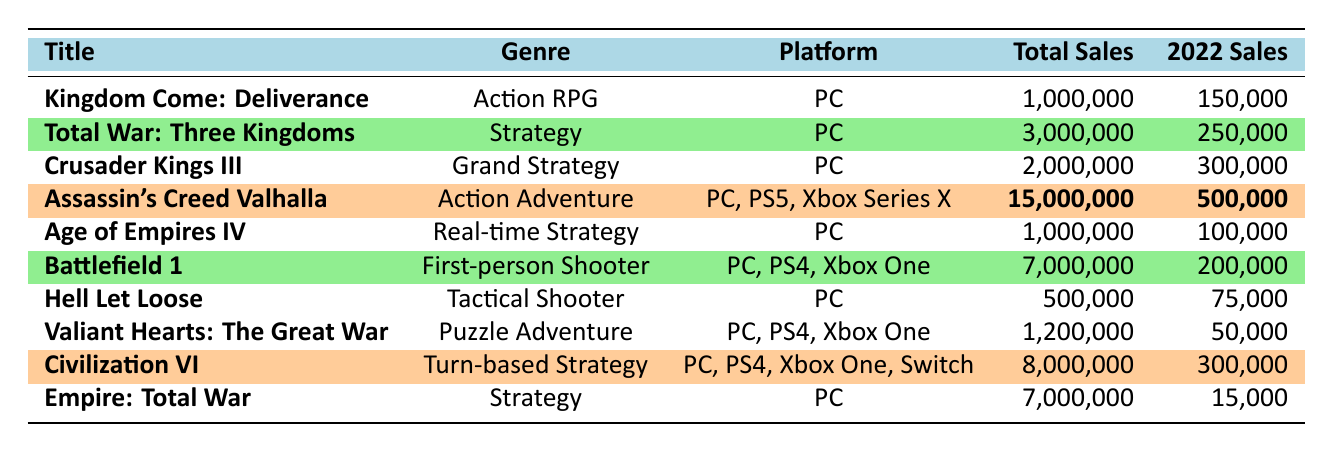What is the genre of "Total War: Three Kingdoms"? The table shows the title "Total War: Three Kingdoms" in the first column and the genre listed next to it in the second column. The genre is "Strategy."
Answer: Strategy How many copies of "Assassin's Creed Valhalla" sold in 2022? The row for "Assassin's Creed Valhalla" states that its sales in 2022 were 500,000 copies.
Answer: 500,000 Which game had the highest total sales? Looking at the total sales column, "Assassin's Creed Valhalla" has the highest value of 15,000,000 total sales compared to other titles.
Answer: Assassin's Creed Valhalla What is the total sales of "Empire: Total War"? The table lists "Empire: Total War" with total sales of 7,000,000 in the total sales column.
Answer: 7,000,000 What is the average sales of all games listed for 2022? To find the average, sum all 2022 sales: 150,000 + 250,000 + 300,000 + 500,000 + 100,000 + 200,000 + 75,000 + 50,000 + 300,000 + 15,000 = 1,640,000; then divide by the number of games, which is 10. The average is 1,640,000 / 10 = 164,000.
Answer: 164,000 Is "Hell Let Loose" a first-person shooter? The table shows that "Hell Let Loose" is categorized under the genre "Tactical Shooter" in the genre column, which is not the same as "First-person Shooter."
Answer: No How many total copies were sold for all the listed games? Adding all the total sales from the table: 1,000,000 + 3,000,000 + 2,000,000 + 15,000,000 + 1,000,000 + 7,000,000 + 500,000 + 1,200,000 + 8,000,000 + 7,000,000 equals 45,700,000 copies sold in total.
Answer: 45,700,000 Which genre has the highest sales in 2022? The game with the highest sales in 2022 is "Assassin's Creed Valhalla" in the Action Adventure genre with 500,000 copies, which is higher than the other genres.
Answer: Action Adventure Is the average sales for the "Strategy" genre greater than 200,000? The total sales for the "Strategy" genre games are: "Total War: Three Kingdoms" (250,000) and "Empire: Total War" (15,000). The average is (250,000 + 15,000) / 2 = 132,500, which is less than 200,000.
Answer: No What percentage of total sales did "Civilization VI" contribute in 2022? "Civilization VI" sold 300,000 copies in 2022. To calculate the percentage, (300,000 / 1,640,000) * 100 = 18.29%.
Answer: 18.29% 